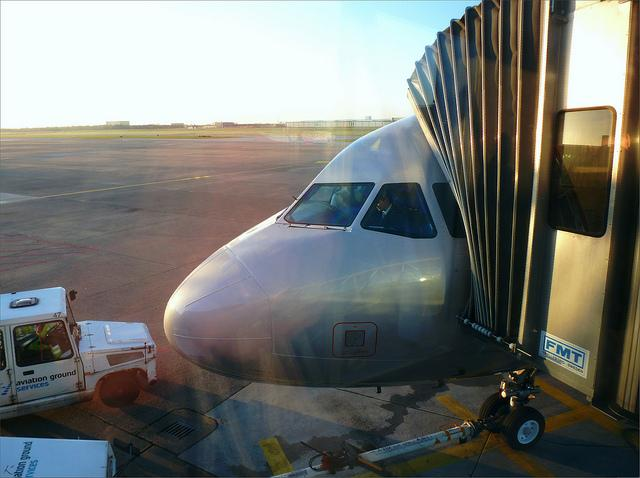What is this part of the plane known as? Please explain your reasoning. cockpit. It is the front of the plane. 